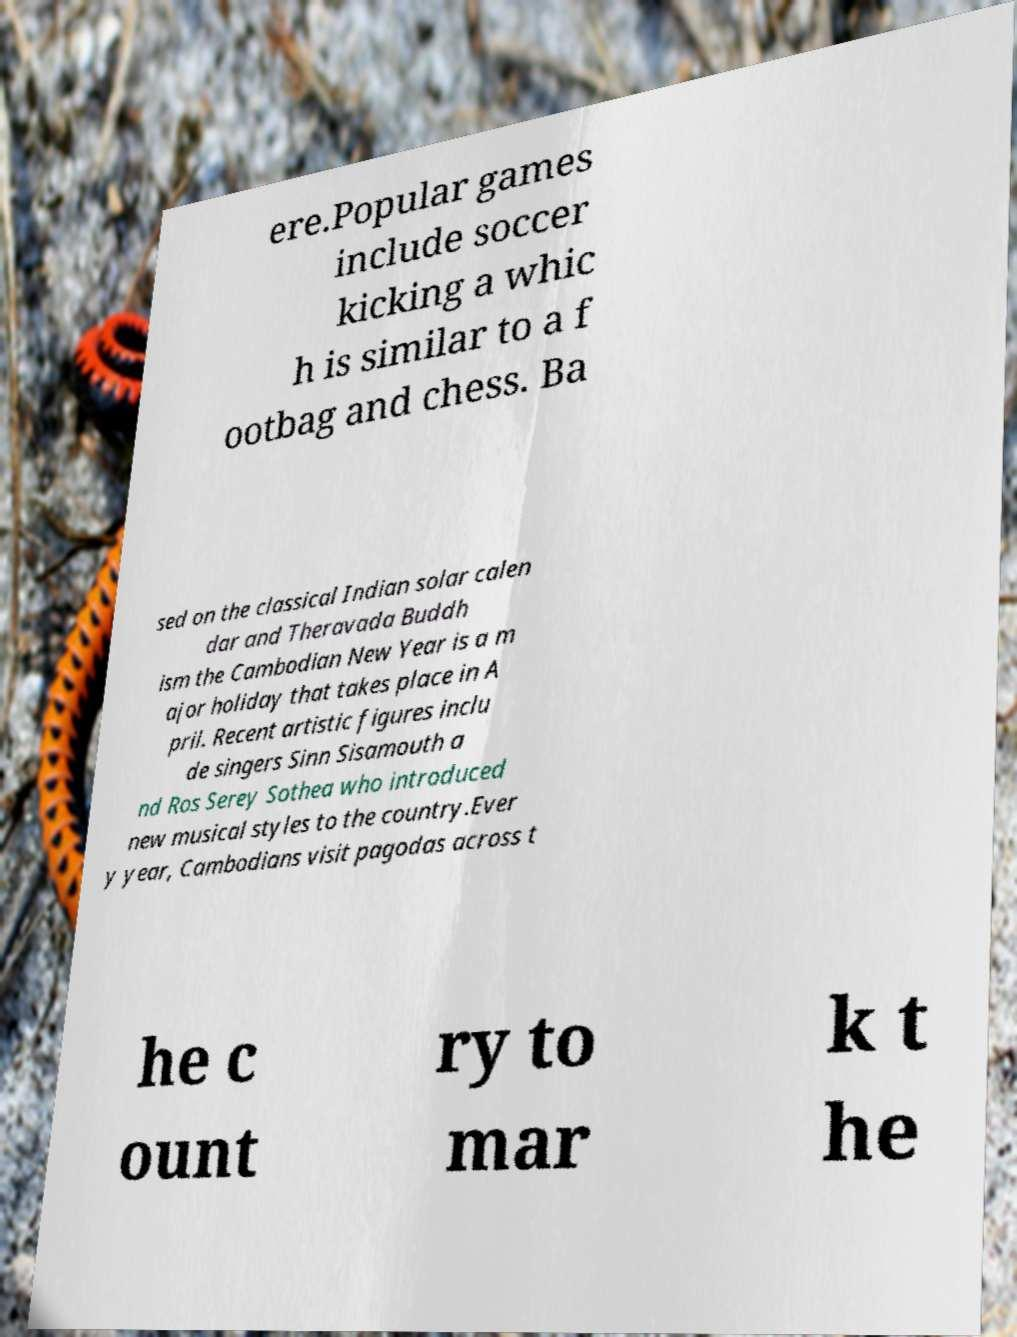There's text embedded in this image that I need extracted. Can you transcribe it verbatim? ere.Popular games include soccer kicking a whic h is similar to a f ootbag and chess. Ba sed on the classical Indian solar calen dar and Theravada Buddh ism the Cambodian New Year is a m ajor holiday that takes place in A pril. Recent artistic figures inclu de singers Sinn Sisamouth a nd Ros Serey Sothea who introduced new musical styles to the country.Ever y year, Cambodians visit pagodas across t he c ount ry to mar k t he 